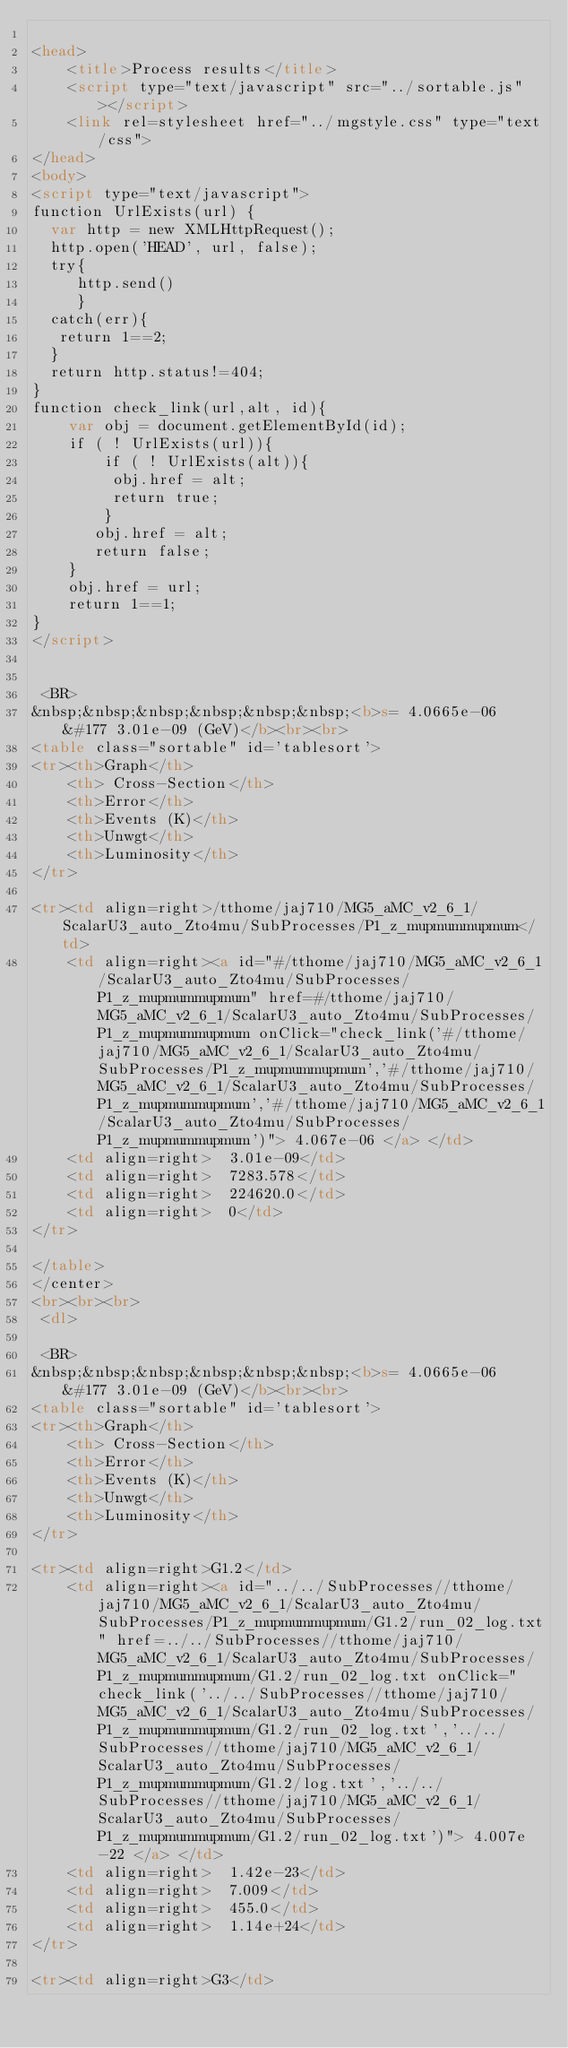<code> <loc_0><loc_0><loc_500><loc_500><_HTML_>
<head>
    <title>Process results</title>
    <script type="text/javascript" src="../sortable.js"></script>
    <link rel=stylesheet href="../mgstyle.css" type="text/css">
</head>
<body>
<script type="text/javascript">
function UrlExists(url) {
  var http = new XMLHttpRequest();
  http.open('HEAD', url, false);
  try{
     http.send()
     }
  catch(err){
   return 1==2;
  }
  return http.status!=404;
}
function check_link(url,alt, id){
    var obj = document.getElementById(id);
    if ( ! UrlExists(url)){
        if ( ! UrlExists(alt)){
         obj.href = alt;
         return true;
        }
       obj.href = alt;
       return false;
    }
    obj.href = url;
    return 1==1;
}
</script>
  

 <BR>
&nbsp;&nbsp;&nbsp;&nbsp;&nbsp;&nbsp;<b>s= 4.0665e-06 &#177 3.01e-09 (GeV)</b><br><br>
<table class="sortable" id='tablesort'>
<tr><th>Graph</th>
    <th> Cross-Section</th>
    <th>Error</th>
    <th>Events (K)</th>
    <th>Unwgt</th>
    <th>Luminosity</th>
</tr>

<tr><td align=right>/tthome/jaj710/MG5_aMC_v2_6_1/ScalarU3_auto_Zto4mu/SubProcesses/P1_z_mupmummupmum</td>
    <td align=right><a id="#/tthome/jaj710/MG5_aMC_v2_6_1/ScalarU3_auto_Zto4mu/SubProcesses/P1_z_mupmummupmum" href=#/tthome/jaj710/MG5_aMC_v2_6_1/ScalarU3_auto_Zto4mu/SubProcesses/P1_z_mupmummupmum onClick="check_link('#/tthome/jaj710/MG5_aMC_v2_6_1/ScalarU3_auto_Zto4mu/SubProcesses/P1_z_mupmummupmum','#/tthome/jaj710/MG5_aMC_v2_6_1/ScalarU3_auto_Zto4mu/SubProcesses/P1_z_mupmummupmum','#/tthome/jaj710/MG5_aMC_v2_6_1/ScalarU3_auto_Zto4mu/SubProcesses/P1_z_mupmummupmum')"> 4.067e-06 </a> </td>
    <td align=right>  3.01e-09</td>
    <td align=right>  7283.578</td>
    <td align=right>  224620.0</td>
    <td align=right>  0</td>
</tr>

</table>
</center>
<br><br><br>
 <dl>  

 <BR>
&nbsp;&nbsp;&nbsp;&nbsp;&nbsp;&nbsp;<b>s= 4.0665e-06 &#177 3.01e-09 (GeV)</b><br><br>
<table class="sortable" id='tablesort'>
<tr><th>Graph</th>
    <th> Cross-Section</th>
    <th>Error</th>
    <th>Events (K)</th>
    <th>Unwgt</th>
    <th>Luminosity</th>
</tr>

<tr><td align=right>G1.2</td>
    <td align=right><a id="../../SubProcesses//tthome/jaj710/MG5_aMC_v2_6_1/ScalarU3_auto_Zto4mu/SubProcesses/P1_z_mupmummupmum/G1.2/run_02_log.txt" href=../../SubProcesses//tthome/jaj710/MG5_aMC_v2_6_1/ScalarU3_auto_Zto4mu/SubProcesses/P1_z_mupmummupmum/G1.2/run_02_log.txt onClick="check_link('../../SubProcesses//tthome/jaj710/MG5_aMC_v2_6_1/ScalarU3_auto_Zto4mu/SubProcesses/P1_z_mupmummupmum/G1.2/run_02_log.txt','../../SubProcesses//tthome/jaj710/MG5_aMC_v2_6_1/ScalarU3_auto_Zto4mu/SubProcesses/P1_z_mupmummupmum/G1.2/log.txt','../../SubProcesses//tthome/jaj710/MG5_aMC_v2_6_1/ScalarU3_auto_Zto4mu/SubProcesses/P1_z_mupmummupmum/G1.2/run_02_log.txt')"> 4.007e-22 </a> </td>
    <td align=right>  1.42e-23</td>
    <td align=right>  7.009</td>
    <td align=right>  455.0</td>
    <td align=right>  1.14e+24</td>
</tr>

<tr><td align=right>G3</td></code> 